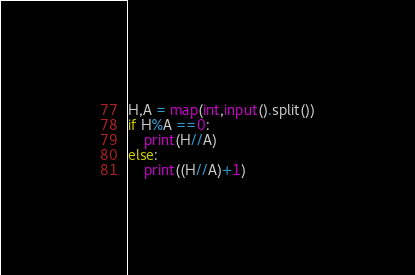Convert code to text. <code><loc_0><loc_0><loc_500><loc_500><_Python_>H,A = map(int,input().split())
if H%A ==0:
    print(H//A)
else:
    print((H//A)+1)</code> 